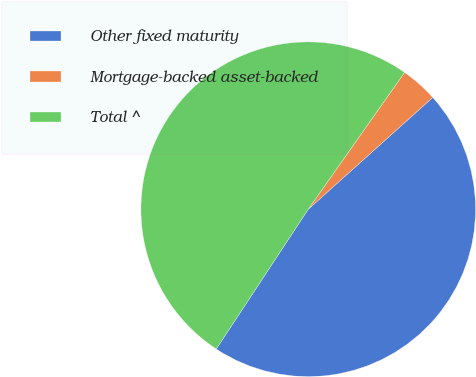<chart> <loc_0><loc_0><loc_500><loc_500><pie_chart><fcel>Other fixed maturity<fcel>Mortgage-backed asset-backed<fcel>Total ^<nl><fcel>45.91%<fcel>3.59%<fcel>50.5%<nl></chart> 